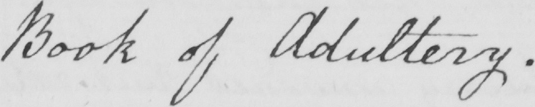What is written in this line of handwriting? Book of Adultery . 